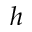<formula> <loc_0><loc_0><loc_500><loc_500>h</formula> 